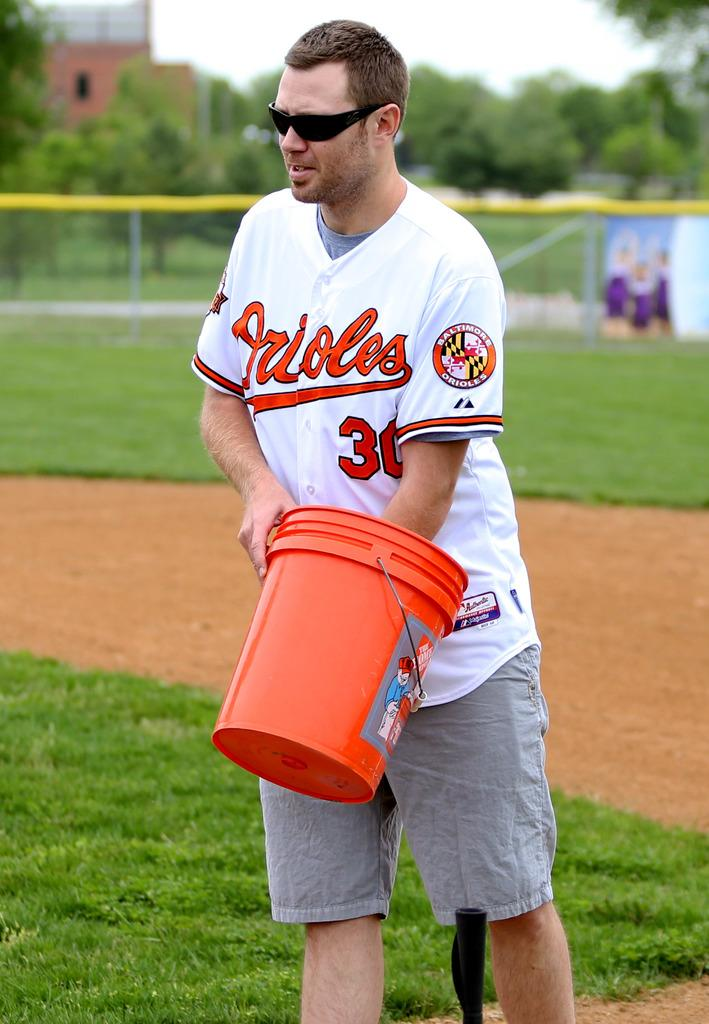<image>
Render a clear and concise summary of the photo. A man wearing sunglasses and an orioles jersey stands on a baseball field with his hand in a bucket 